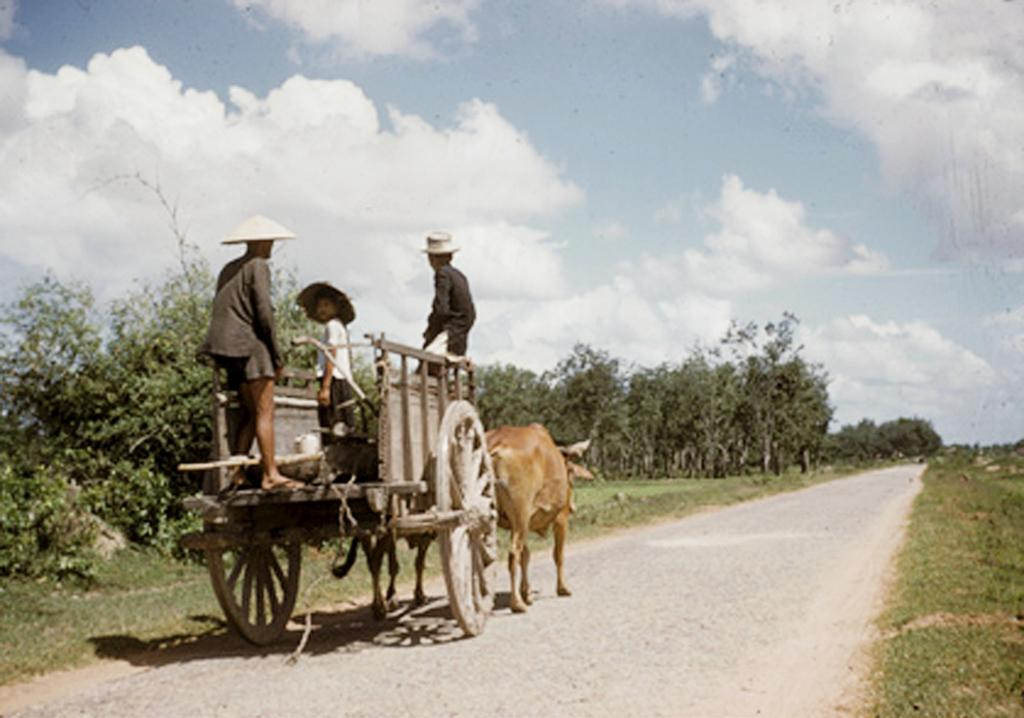Who or what is present in the image? There are people in the image. What are the people doing or riding in the image? The people are on a cow cart. What type of natural environment can be seen in the image? There are trees in the image. What type of pencil can be seen in the image? There is no pencil present in the image. How many doors are visible in the image? There is no door present in the image. 